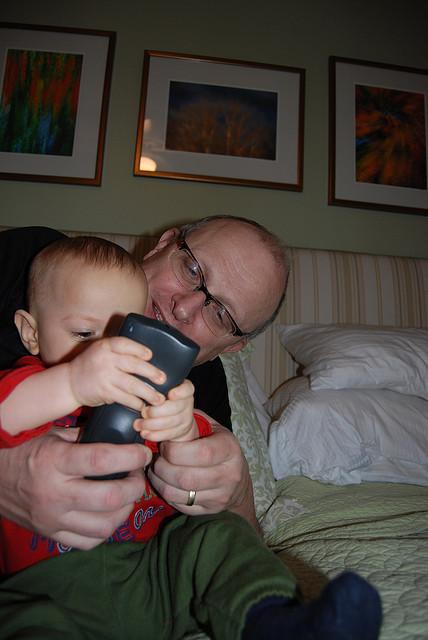What is the baby playing with?

Choices:
A) cellphone
B) remote control
C) calculator
D) toy remote control 